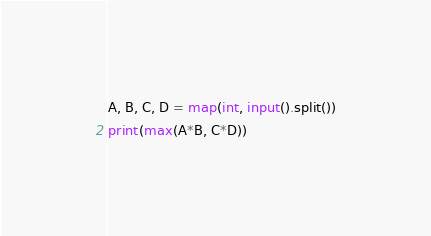<code> <loc_0><loc_0><loc_500><loc_500><_Python_>A, B, C, D = map(int, input().split())
print(max(A*B, C*D))</code> 